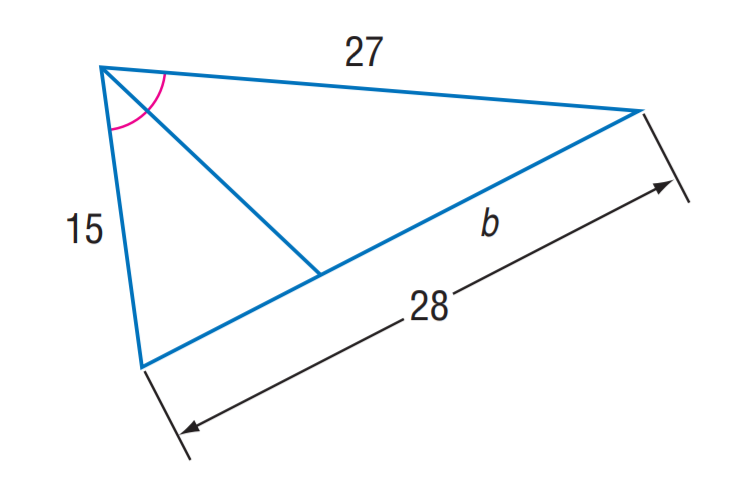Answer the mathemtical geometry problem and directly provide the correct option letter.
Question: Find b.
Choices: A: 15 B: 18 C: 24 D: 27 B 